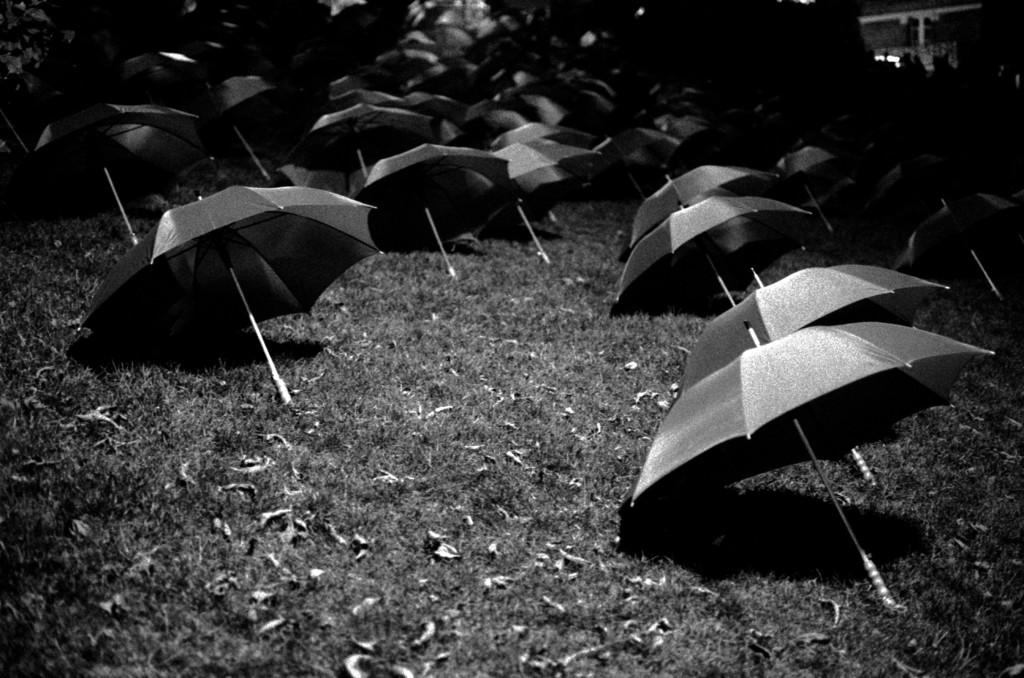What is the color scheme of the image? The image is black and white. What objects are present in the image? There are many umbrellas in the image. Where are the umbrellas located? The umbrellas are on the grass. What is the smell of the umbrellas in the image? Umbrellas do not have a smell, so this question cannot be answered. 